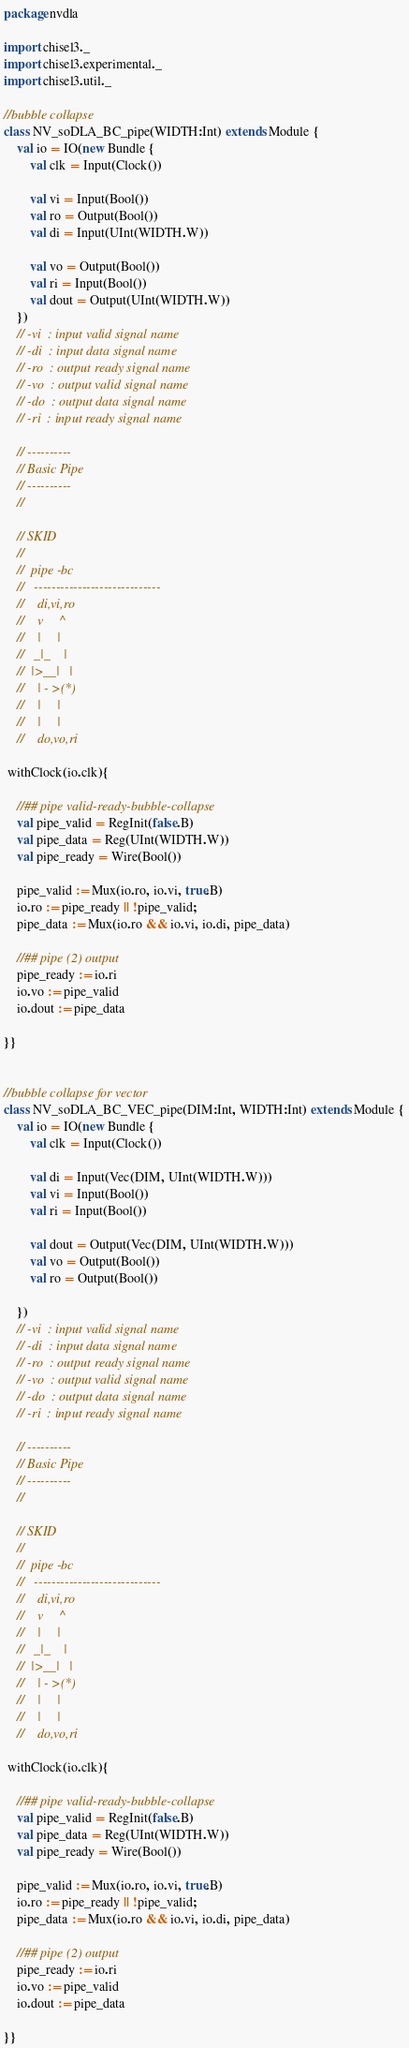Convert code to text. <code><loc_0><loc_0><loc_500><loc_500><_Scala_>package nvdla

import chisel3._
import chisel3.experimental._
import chisel3.util._

//bubble collapse
class NV_soDLA_BC_pipe(WIDTH:Int) extends Module {
    val io = IO(new Bundle {  
        val clk = Input(Clock()) 

        val vi = Input(Bool())
        val ro = Output(Bool())
        val di = Input(UInt(WIDTH.W)) 
            
        val vo = Output(Bool()) 
        val ri = Input(Bool())
        val dout = Output(UInt(WIDTH.W))
    })
    // -vi  : input valid signal name
    // -di  : input data signal name
    // -ro  : output ready signal name
    // -vo  : output valid signal name
    // -do  : output data signal name
    // -ri  : input ready signal name

    // ----------
    // Basic Pipe
    // ----------
    // 
        
    // SKID
    //
    //  pipe -bc                          
    //   ----------------------------- 
    //    di,vi,ro      
    //    v     ^        
    //    |     |       
    //   _|_    |        
    //  |>__|   |      
    //    | - >(*)        
    //    |     |      
    //    |     |       
    //    do,vo,ri     
 
 withClock(io.clk){    
     
    //## pipe valid-ready-bubble-collapse
    val pipe_valid = RegInit(false.B)
    val pipe_data = Reg(UInt(WIDTH.W))
    val pipe_ready = Wire(Bool())

    pipe_valid := Mux(io.ro, io.vi, true.B)
    io.ro := pipe_ready || !pipe_valid;
    pipe_data := Mux(io.ro && io.vi, io.di, pipe_data)

    //## pipe (2) output
    pipe_ready := io.ri
    io.vo := pipe_valid
    io.dout := pipe_data
          
}}


//bubble collapse for vector
class NV_soDLA_BC_VEC_pipe(DIM:Int, WIDTH:Int) extends Module {
    val io = IO(new Bundle {  
        val clk = Input(Clock()) 

        val di = Input(Vec(DIM, UInt(WIDTH.W)))
        val vi = Input(Bool())
        val ri = Input(Bool())

        val dout = Output(Vec(DIM, UInt(WIDTH.W)))
        val vo = Output(Bool()) 
        val ro = Output(Bool())

    })
    // -vi  : input valid signal name
    // -di  : input data signal name
    // -ro  : output ready signal name
    // -vo  : output valid signal name
    // -do  : output data signal name
    // -ri  : input ready signal name

    // ----------
    // Basic Pipe
    // ----------
    // 
        
    // SKID
    //
    //  pipe -bc                          
    //   ----------------------------- 
    //    di,vi,ro      
    //    v     ^        
    //    |     |       
    //   _|_    |        
    //  |>__|   |      
    //    | - >(*)        
    //    |     |      
    //    |     |       
    //    do,vo,ri     
 
 withClock(io.clk){    
     
    //## pipe valid-ready-bubble-collapse
    val pipe_valid = RegInit(false.B)
    val pipe_data = Reg(UInt(WIDTH.W))
    val pipe_ready = Wire(Bool())

    pipe_valid := Mux(io.ro, io.vi, true.B)
    io.ro := pipe_ready || !pipe_valid;
    pipe_data := Mux(io.ro && io.vi, io.di, pipe_data)

    //## pipe (2) output
    pipe_ready := io.ri
    io.vo := pipe_valid
    io.dout := pipe_data
          
}}</code> 